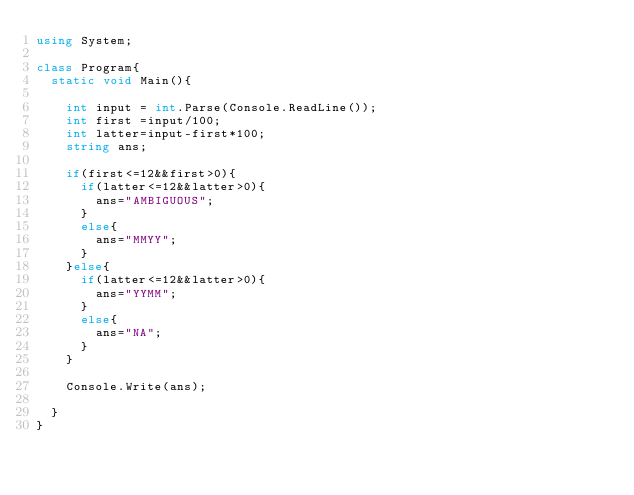Convert code to text. <code><loc_0><loc_0><loc_500><loc_500><_C#_>using System;
 
class Program{
  static void Main(){
    
    int input = int.Parse(Console.ReadLine());
    int first =input/100;
    int latter=input-first*100;
    string ans;
    
    if(first<=12&&first>0){
      if(latter<=12&&latter>0){
        ans="AMBIGUOUS";
      }
      else{
        ans="MMYY";
      }
    }else{
      if(latter<=12&&latter>0){
        ans="YYMM";
      }
      else{
        ans="NA";
      }
    }

    Console.Write(ans);
    
  }
}</code> 